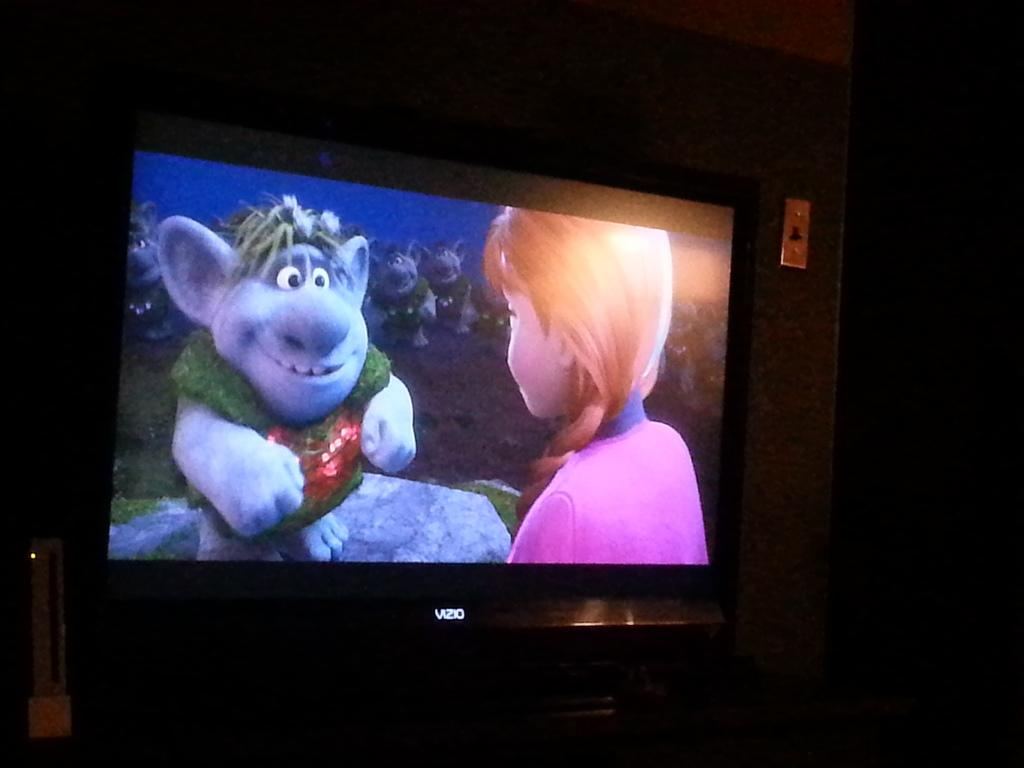<image>
Write a terse but informative summary of the picture. A Vizio television is on in a dark room, showing a scene from the movie Frozen 